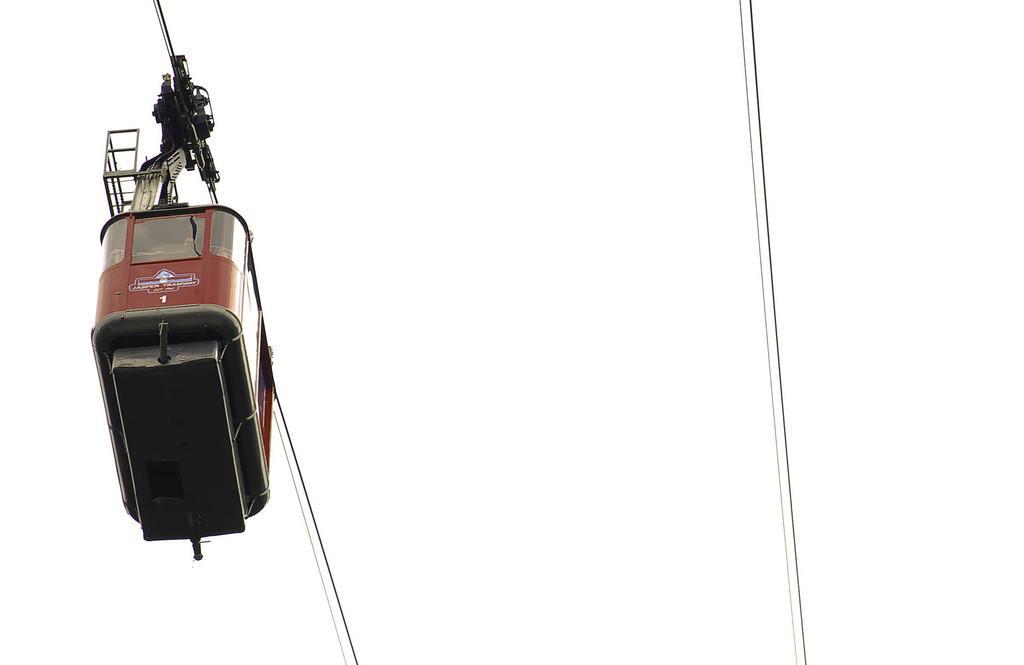Could you give a brief overview of what you see in this image? In the image we can see there is a ropeway wheel car. 